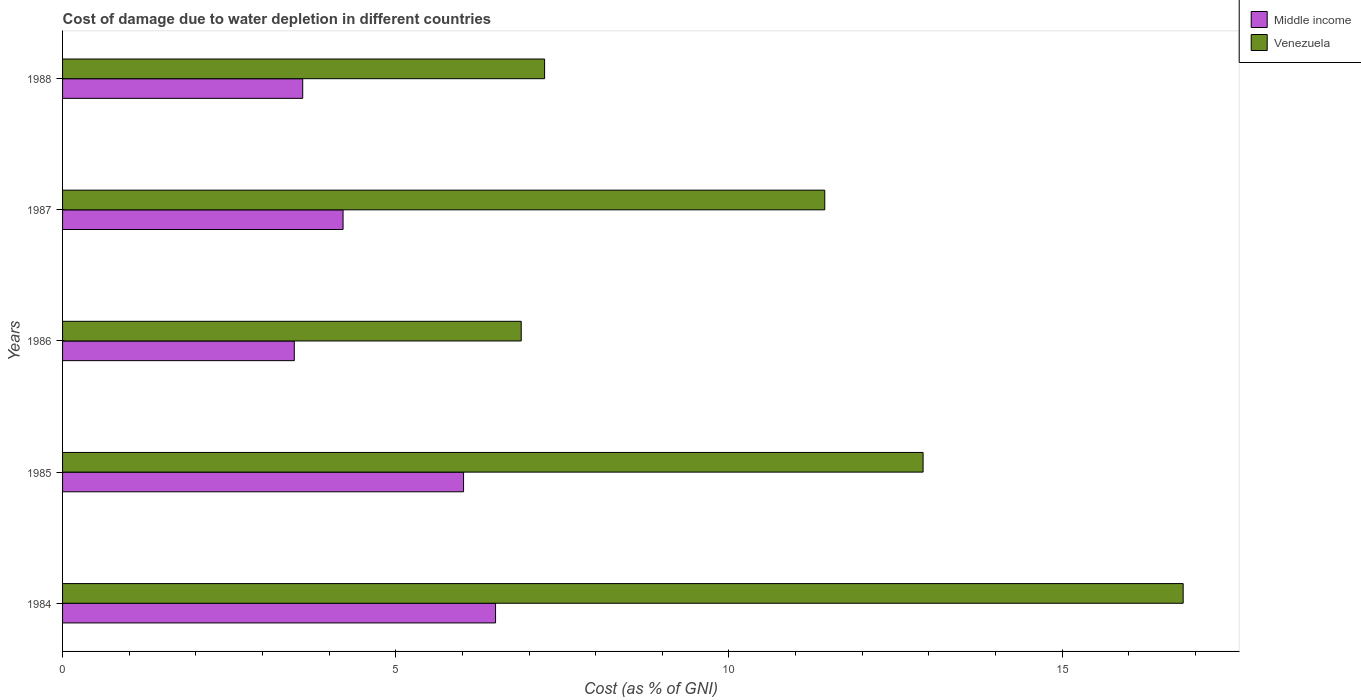How many groups of bars are there?
Your response must be concise. 5. Are the number of bars on each tick of the Y-axis equal?
Give a very brief answer. Yes. How many bars are there on the 1st tick from the top?
Your answer should be compact. 2. How many bars are there on the 2nd tick from the bottom?
Provide a short and direct response. 2. What is the cost of damage caused due to water depletion in Venezuela in 1986?
Your response must be concise. 6.88. Across all years, what is the maximum cost of damage caused due to water depletion in Middle income?
Provide a short and direct response. 6.5. Across all years, what is the minimum cost of damage caused due to water depletion in Venezuela?
Keep it short and to the point. 6.88. In which year was the cost of damage caused due to water depletion in Venezuela minimum?
Give a very brief answer. 1986. What is the total cost of damage caused due to water depletion in Venezuela in the graph?
Keep it short and to the point. 55.29. What is the difference between the cost of damage caused due to water depletion in Middle income in 1984 and that in 1986?
Your response must be concise. 3.02. What is the difference between the cost of damage caused due to water depletion in Middle income in 1985 and the cost of damage caused due to water depletion in Venezuela in 1984?
Provide a short and direct response. -10.8. What is the average cost of damage caused due to water depletion in Venezuela per year?
Ensure brevity in your answer.  11.06. In the year 1985, what is the difference between the cost of damage caused due to water depletion in Venezuela and cost of damage caused due to water depletion in Middle income?
Provide a short and direct response. 6.9. In how many years, is the cost of damage caused due to water depletion in Middle income greater than 5 %?
Provide a short and direct response. 2. What is the ratio of the cost of damage caused due to water depletion in Venezuela in 1984 to that in 1987?
Offer a very short reply. 1.47. Is the difference between the cost of damage caused due to water depletion in Venezuela in 1985 and 1988 greater than the difference between the cost of damage caused due to water depletion in Middle income in 1985 and 1988?
Your response must be concise. Yes. What is the difference between the highest and the second highest cost of damage caused due to water depletion in Venezuela?
Your response must be concise. 3.9. What is the difference between the highest and the lowest cost of damage caused due to water depletion in Venezuela?
Your answer should be very brief. 9.93. Is the sum of the cost of damage caused due to water depletion in Venezuela in 1984 and 1987 greater than the maximum cost of damage caused due to water depletion in Middle income across all years?
Provide a succinct answer. Yes. How many bars are there?
Make the answer very short. 10. How many years are there in the graph?
Give a very brief answer. 5. Does the graph contain any zero values?
Give a very brief answer. No. Does the graph contain grids?
Your answer should be compact. No. How many legend labels are there?
Offer a very short reply. 2. What is the title of the graph?
Keep it short and to the point. Cost of damage due to water depletion in different countries. Does "Philippines" appear as one of the legend labels in the graph?
Give a very brief answer. No. What is the label or title of the X-axis?
Provide a short and direct response. Cost (as % of GNI). What is the Cost (as % of GNI) in Middle income in 1984?
Your answer should be compact. 6.5. What is the Cost (as % of GNI) of Venezuela in 1984?
Offer a terse response. 16.82. What is the Cost (as % of GNI) of Middle income in 1985?
Your answer should be compact. 6.02. What is the Cost (as % of GNI) in Venezuela in 1985?
Provide a succinct answer. 12.91. What is the Cost (as % of GNI) of Middle income in 1986?
Your answer should be compact. 3.48. What is the Cost (as % of GNI) of Venezuela in 1986?
Ensure brevity in your answer.  6.88. What is the Cost (as % of GNI) of Middle income in 1987?
Your answer should be compact. 4.21. What is the Cost (as % of GNI) of Venezuela in 1987?
Ensure brevity in your answer.  11.44. What is the Cost (as % of GNI) in Middle income in 1988?
Your answer should be very brief. 3.6. What is the Cost (as % of GNI) in Venezuela in 1988?
Your answer should be compact. 7.23. Across all years, what is the maximum Cost (as % of GNI) in Middle income?
Your response must be concise. 6.5. Across all years, what is the maximum Cost (as % of GNI) in Venezuela?
Your answer should be very brief. 16.82. Across all years, what is the minimum Cost (as % of GNI) of Middle income?
Give a very brief answer. 3.48. Across all years, what is the minimum Cost (as % of GNI) of Venezuela?
Your answer should be compact. 6.88. What is the total Cost (as % of GNI) in Middle income in the graph?
Your answer should be very brief. 23.81. What is the total Cost (as % of GNI) in Venezuela in the graph?
Provide a short and direct response. 55.28. What is the difference between the Cost (as % of GNI) of Middle income in 1984 and that in 1985?
Provide a succinct answer. 0.48. What is the difference between the Cost (as % of GNI) of Venezuela in 1984 and that in 1985?
Offer a very short reply. 3.9. What is the difference between the Cost (as % of GNI) in Middle income in 1984 and that in 1986?
Provide a short and direct response. 3.02. What is the difference between the Cost (as % of GNI) in Venezuela in 1984 and that in 1986?
Make the answer very short. 9.93. What is the difference between the Cost (as % of GNI) in Middle income in 1984 and that in 1987?
Your answer should be very brief. 2.29. What is the difference between the Cost (as % of GNI) of Venezuela in 1984 and that in 1987?
Make the answer very short. 5.38. What is the difference between the Cost (as % of GNI) of Middle income in 1984 and that in 1988?
Give a very brief answer. 2.89. What is the difference between the Cost (as % of GNI) in Venezuela in 1984 and that in 1988?
Provide a succinct answer. 9.58. What is the difference between the Cost (as % of GNI) of Middle income in 1985 and that in 1986?
Your answer should be compact. 2.54. What is the difference between the Cost (as % of GNI) in Venezuela in 1985 and that in 1986?
Give a very brief answer. 6.03. What is the difference between the Cost (as % of GNI) of Middle income in 1985 and that in 1987?
Your answer should be very brief. 1.81. What is the difference between the Cost (as % of GNI) in Venezuela in 1985 and that in 1987?
Provide a short and direct response. 1.48. What is the difference between the Cost (as % of GNI) of Middle income in 1985 and that in 1988?
Your answer should be compact. 2.41. What is the difference between the Cost (as % of GNI) in Venezuela in 1985 and that in 1988?
Your answer should be very brief. 5.68. What is the difference between the Cost (as % of GNI) in Middle income in 1986 and that in 1987?
Provide a short and direct response. -0.73. What is the difference between the Cost (as % of GNI) of Venezuela in 1986 and that in 1987?
Your answer should be very brief. -4.56. What is the difference between the Cost (as % of GNI) in Middle income in 1986 and that in 1988?
Provide a short and direct response. -0.13. What is the difference between the Cost (as % of GNI) in Venezuela in 1986 and that in 1988?
Make the answer very short. -0.35. What is the difference between the Cost (as % of GNI) in Middle income in 1987 and that in 1988?
Provide a succinct answer. 0.61. What is the difference between the Cost (as % of GNI) in Venezuela in 1987 and that in 1988?
Ensure brevity in your answer.  4.2. What is the difference between the Cost (as % of GNI) in Middle income in 1984 and the Cost (as % of GNI) in Venezuela in 1985?
Your response must be concise. -6.42. What is the difference between the Cost (as % of GNI) of Middle income in 1984 and the Cost (as % of GNI) of Venezuela in 1986?
Your answer should be compact. -0.38. What is the difference between the Cost (as % of GNI) of Middle income in 1984 and the Cost (as % of GNI) of Venezuela in 1987?
Keep it short and to the point. -4.94. What is the difference between the Cost (as % of GNI) of Middle income in 1984 and the Cost (as % of GNI) of Venezuela in 1988?
Keep it short and to the point. -0.74. What is the difference between the Cost (as % of GNI) in Middle income in 1985 and the Cost (as % of GNI) in Venezuela in 1986?
Your answer should be very brief. -0.87. What is the difference between the Cost (as % of GNI) in Middle income in 1985 and the Cost (as % of GNI) in Venezuela in 1987?
Give a very brief answer. -5.42. What is the difference between the Cost (as % of GNI) of Middle income in 1985 and the Cost (as % of GNI) of Venezuela in 1988?
Give a very brief answer. -1.22. What is the difference between the Cost (as % of GNI) in Middle income in 1986 and the Cost (as % of GNI) in Venezuela in 1987?
Keep it short and to the point. -7.96. What is the difference between the Cost (as % of GNI) in Middle income in 1986 and the Cost (as % of GNI) in Venezuela in 1988?
Make the answer very short. -3.76. What is the difference between the Cost (as % of GNI) in Middle income in 1987 and the Cost (as % of GNI) in Venezuela in 1988?
Give a very brief answer. -3.02. What is the average Cost (as % of GNI) in Middle income per year?
Ensure brevity in your answer.  4.76. What is the average Cost (as % of GNI) of Venezuela per year?
Ensure brevity in your answer.  11.06. In the year 1984, what is the difference between the Cost (as % of GNI) in Middle income and Cost (as % of GNI) in Venezuela?
Give a very brief answer. -10.32. In the year 1985, what is the difference between the Cost (as % of GNI) of Middle income and Cost (as % of GNI) of Venezuela?
Your answer should be very brief. -6.9. In the year 1986, what is the difference between the Cost (as % of GNI) of Middle income and Cost (as % of GNI) of Venezuela?
Provide a succinct answer. -3.41. In the year 1987, what is the difference between the Cost (as % of GNI) in Middle income and Cost (as % of GNI) in Venezuela?
Provide a short and direct response. -7.23. In the year 1988, what is the difference between the Cost (as % of GNI) of Middle income and Cost (as % of GNI) of Venezuela?
Offer a terse response. -3.63. What is the ratio of the Cost (as % of GNI) in Middle income in 1984 to that in 1985?
Give a very brief answer. 1.08. What is the ratio of the Cost (as % of GNI) in Venezuela in 1984 to that in 1985?
Make the answer very short. 1.3. What is the ratio of the Cost (as % of GNI) in Middle income in 1984 to that in 1986?
Offer a terse response. 1.87. What is the ratio of the Cost (as % of GNI) in Venezuela in 1984 to that in 1986?
Ensure brevity in your answer.  2.44. What is the ratio of the Cost (as % of GNI) in Middle income in 1984 to that in 1987?
Keep it short and to the point. 1.54. What is the ratio of the Cost (as % of GNI) of Venezuela in 1984 to that in 1987?
Your answer should be compact. 1.47. What is the ratio of the Cost (as % of GNI) of Middle income in 1984 to that in 1988?
Your answer should be very brief. 1.8. What is the ratio of the Cost (as % of GNI) in Venezuela in 1984 to that in 1988?
Ensure brevity in your answer.  2.32. What is the ratio of the Cost (as % of GNI) in Middle income in 1985 to that in 1986?
Provide a succinct answer. 1.73. What is the ratio of the Cost (as % of GNI) in Venezuela in 1985 to that in 1986?
Keep it short and to the point. 1.88. What is the ratio of the Cost (as % of GNI) in Middle income in 1985 to that in 1987?
Offer a terse response. 1.43. What is the ratio of the Cost (as % of GNI) in Venezuela in 1985 to that in 1987?
Your response must be concise. 1.13. What is the ratio of the Cost (as % of GNI) of Middle income in 1985 to that in 1988?
Give a very brief answer. 1.67. What is the ratio of the Cost (as % of GNI) of Venezuela in 1985 to that in 1988?
Provide a short and direct response. 1.79. What is the ratio of the Cost (as % of GNI) in Middle income in 1986 to that in 1987?
Ensure brevity in your answer.  0.83. What is the ratio of the Cost (as % of GNI) of Venezuela in 1986 to that in 1987?
Your response must be concise. 0.6. What is the ratio of the Cost (as % of GNI) of Middle income in 1986 to that in 1988?
Your response must be concise. 0.96. What is the ratio of the Cost (as % of GNI) in Venezuela in 1986 to that in 1988?
Your answer should be compact. 0.95. What is the ratio of the Cost (as % of GNI) in Middle income in 1987 to that in 1988?
Give a very brief answer. 1.17. What is the ratio of the Cost (as % of GNI) of Venezuela in 1987 to that in 1988?
Keep it short and to the point. 1.58. What is the difference between the highest and the second highest Cost (as % of GNI) in Middle income?
Your answer should be very brief. 0.48. What is the difference between the highest and the second highest Cost (as % of GNI) in Venezuela?
Offer a terse response. 3.9. What is the difference between the highest and the lowest Cost (as % of GNI) in Middle income?
Your answer should be very brief. 3.02. What is the difference between the highest and the lowest Cost (as % of GNI) of Venezuela?
Your response must be concise. 9.93. 